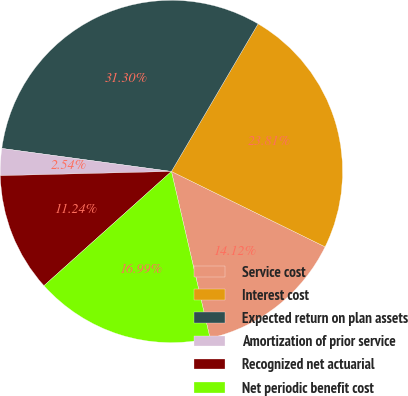Convert chart. <chart><loc_0><loc_0><loc_500><loc_500><pie_chart><fcel>Service cost<fcel>Interest cost<fcel>Expected return on plan assets<fcel>Amortization of prior service<fcel>Recognized net actuarial<fcel>Net periodic benefit cost<nl><fcel>14.12%<fcel>23.81%<fcel>31.3%<fcel>2.54%<fcel>11.24%<fcel>16.99%<nl></chart> 